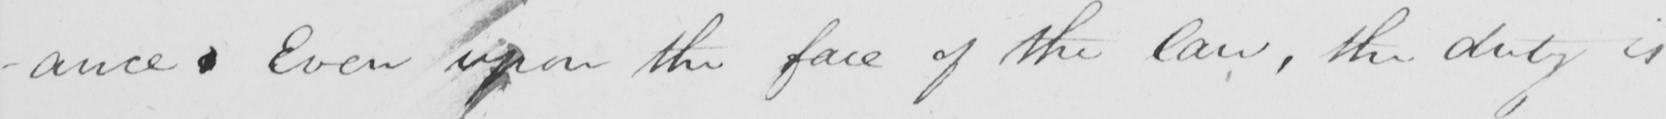Please transcribe the handwritten text in this image. -ance . Even upon the face of the law , the duty is 